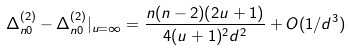<formula> <loc_0><loc_0><loc_500><loc_500>\Delta _ { n 0 } ^ { ( 2 ) } - \Delta _ { n 0 } ^ { ( 2 ) } | _ { u = \infty } = \frac { n ( n - 2 ) ( 2 u + 1 ) } { 4 ( u + 1 ) ^ { 2 } d ^ { 2 } } + O ( 1 / d ^ { 3 } )</formula> 